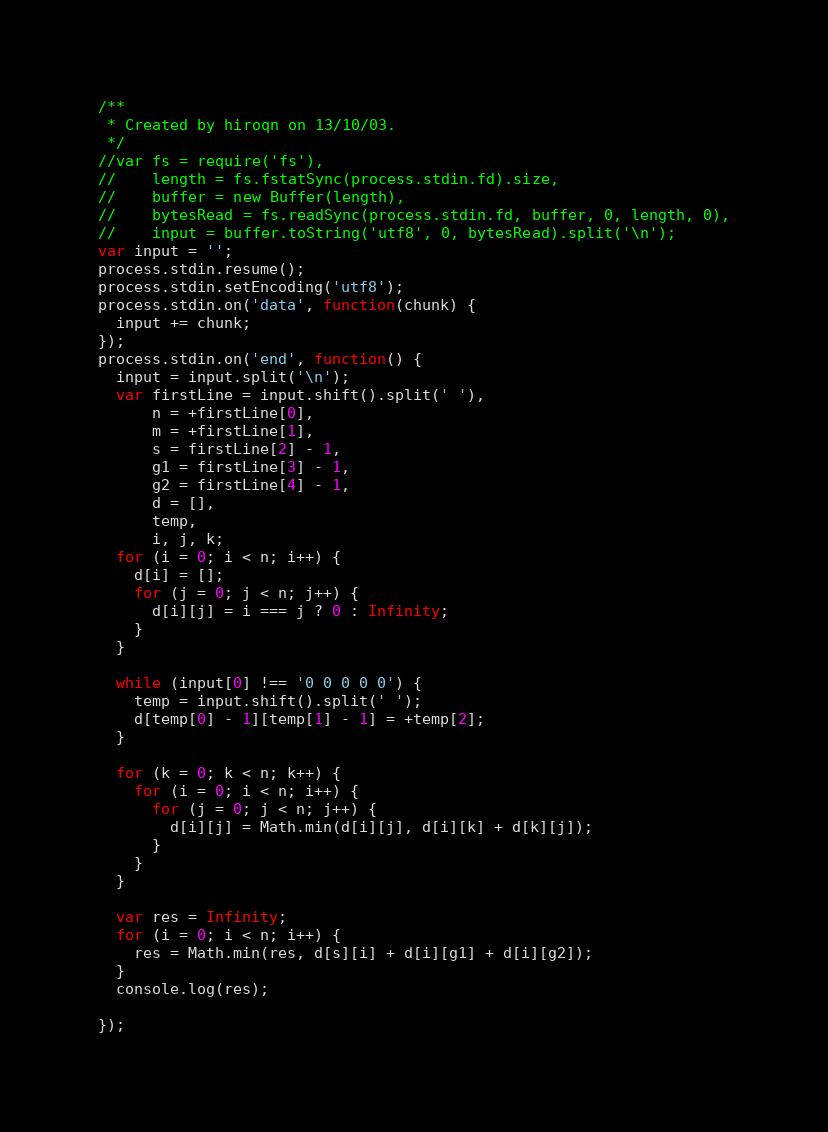Convert code to text. <code><loc_0><loc_0><loc_500><loc_500><_JavaScript_>/**
 * Created by hiroqn on 13/10/03.
 */
//var fs = require('fs'),
//    length = fs.fstatSync(process.stdin.fd).size,
//    buffer = new Buffer(length),
//    bytesRead = fs.readSync(process.stdin.fd, buffer, 0, length, 0),
//    input = buffer.toString('utf8', 0, bytesRead).split('\n');
var input = '';
process.stdin.resume();
process.stdin.setEncoding('utf8');
process.stdin.on('data', function(chunk) {
  input += chunk;
});
process.stdin.on('end', function() {
  input = input.split('\n');
  var firstLine = input.shift().split(' '),
      n = +firstLine[0],
      m = +firstLine[1],
      s = firstLine[2] - 1,
      g1 = firstLine[3] - 1,
      g2 = firstLine[4] - 1,
      d = [],
      temp,
      i, j, k;
  for (i = 0; i < n; i++) {
    d[i] = [];
    for (j = 0; j < n; j++) {
      d[i][j] = i === j ? 0 : Infinity;
    }
  }

  while (input[0] !== '0 0 0 0 0') {
    temp = input.shift().split(' ');
    d[temp[0] - 1][temp[1] - 1] = +temp[2];
  }

  for (k = 0; k < n; k++) {
    for (i = 0; i < n; i++) {
      for (j = 0; j < n; j++) {
        d[i][j] = Math.min(d[i][j], d[i][k] + d[k][j]);
      }
    }
  }

  var res = Infinity;
  for (i = 0; i < n; i++) {
    res = Math.min(res, d[s][i] + d[i][g1] + d[i][g2]);
  }
  console.log(res);

});</code> 